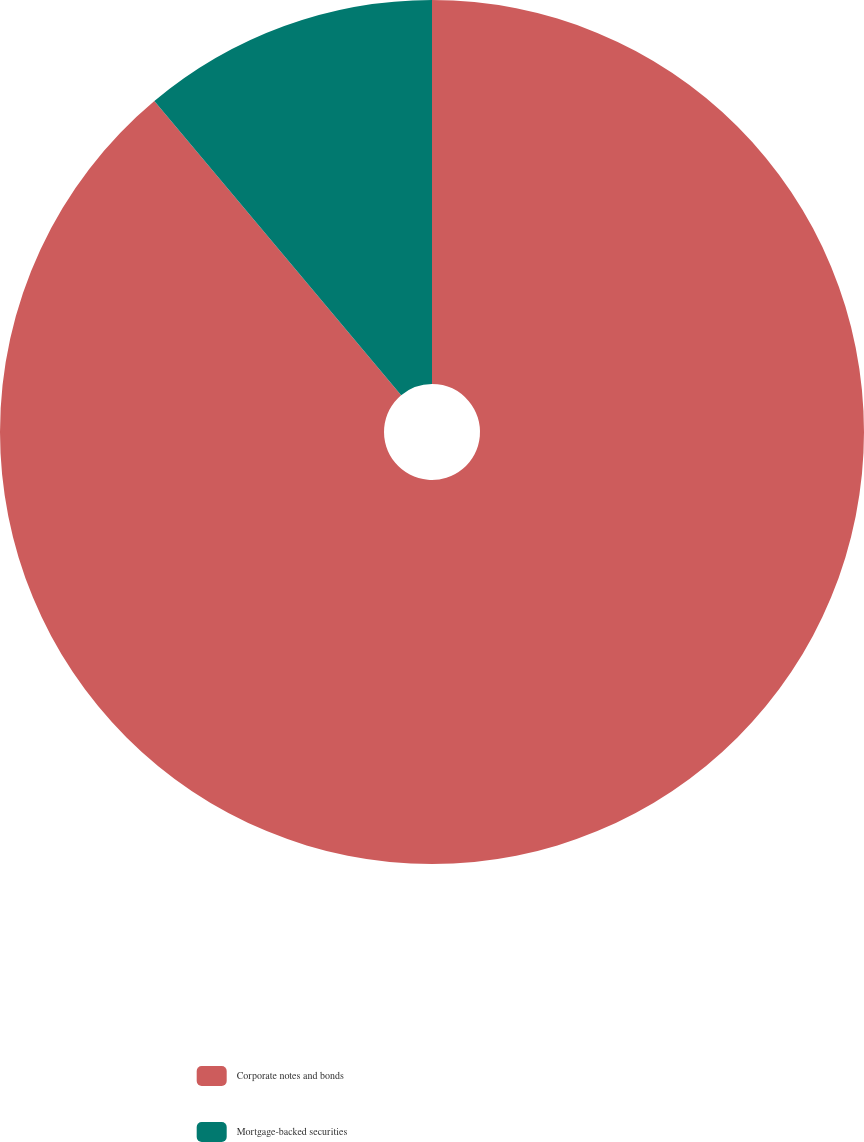Convert chart to OTSL. <chart><loc_0><loc_0><loc_500><loc_500><pie_chart><fcel>Corporate notes and bonds<fcel>Mortgage-backed securities<nl><fcel>88.89%<fcel>11.11%<nl></chart> 